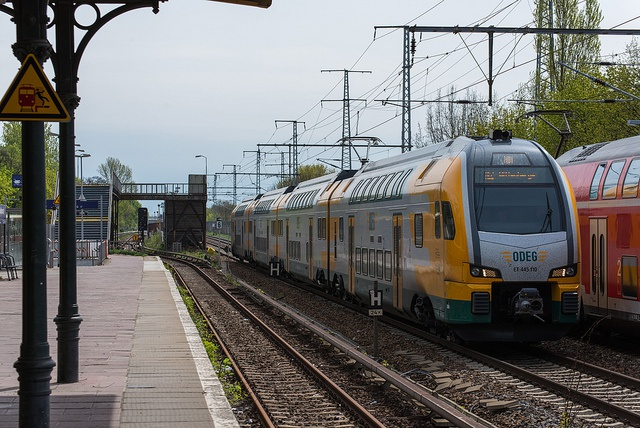Describe the objects in this image and their specific colors. I can see train in black, gray, maroon, and darkblue tones, train in black, maroon, darkgray, and gray tones, and bench in black, gray, darkgray, and purple tones in this image. 